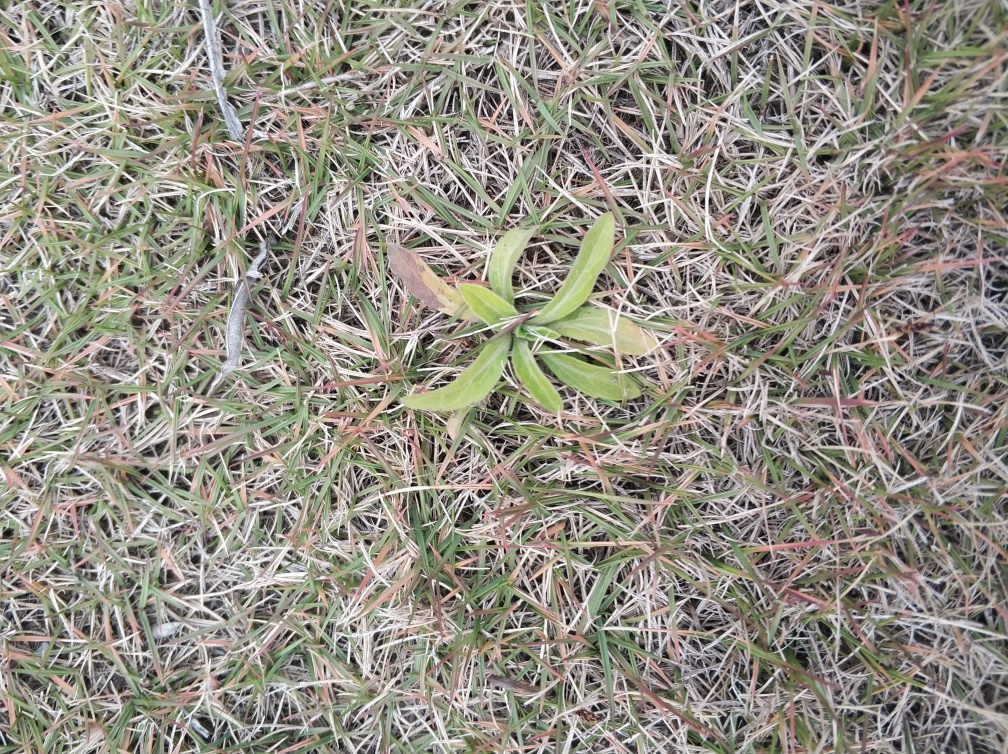Is there sufficient lighting in the image? The image displays appropriate levels of illumination that allow us to discern the details within it, such as the variety of grass blades and the different shades of green, which suggests there is a good amount of natural light present. 